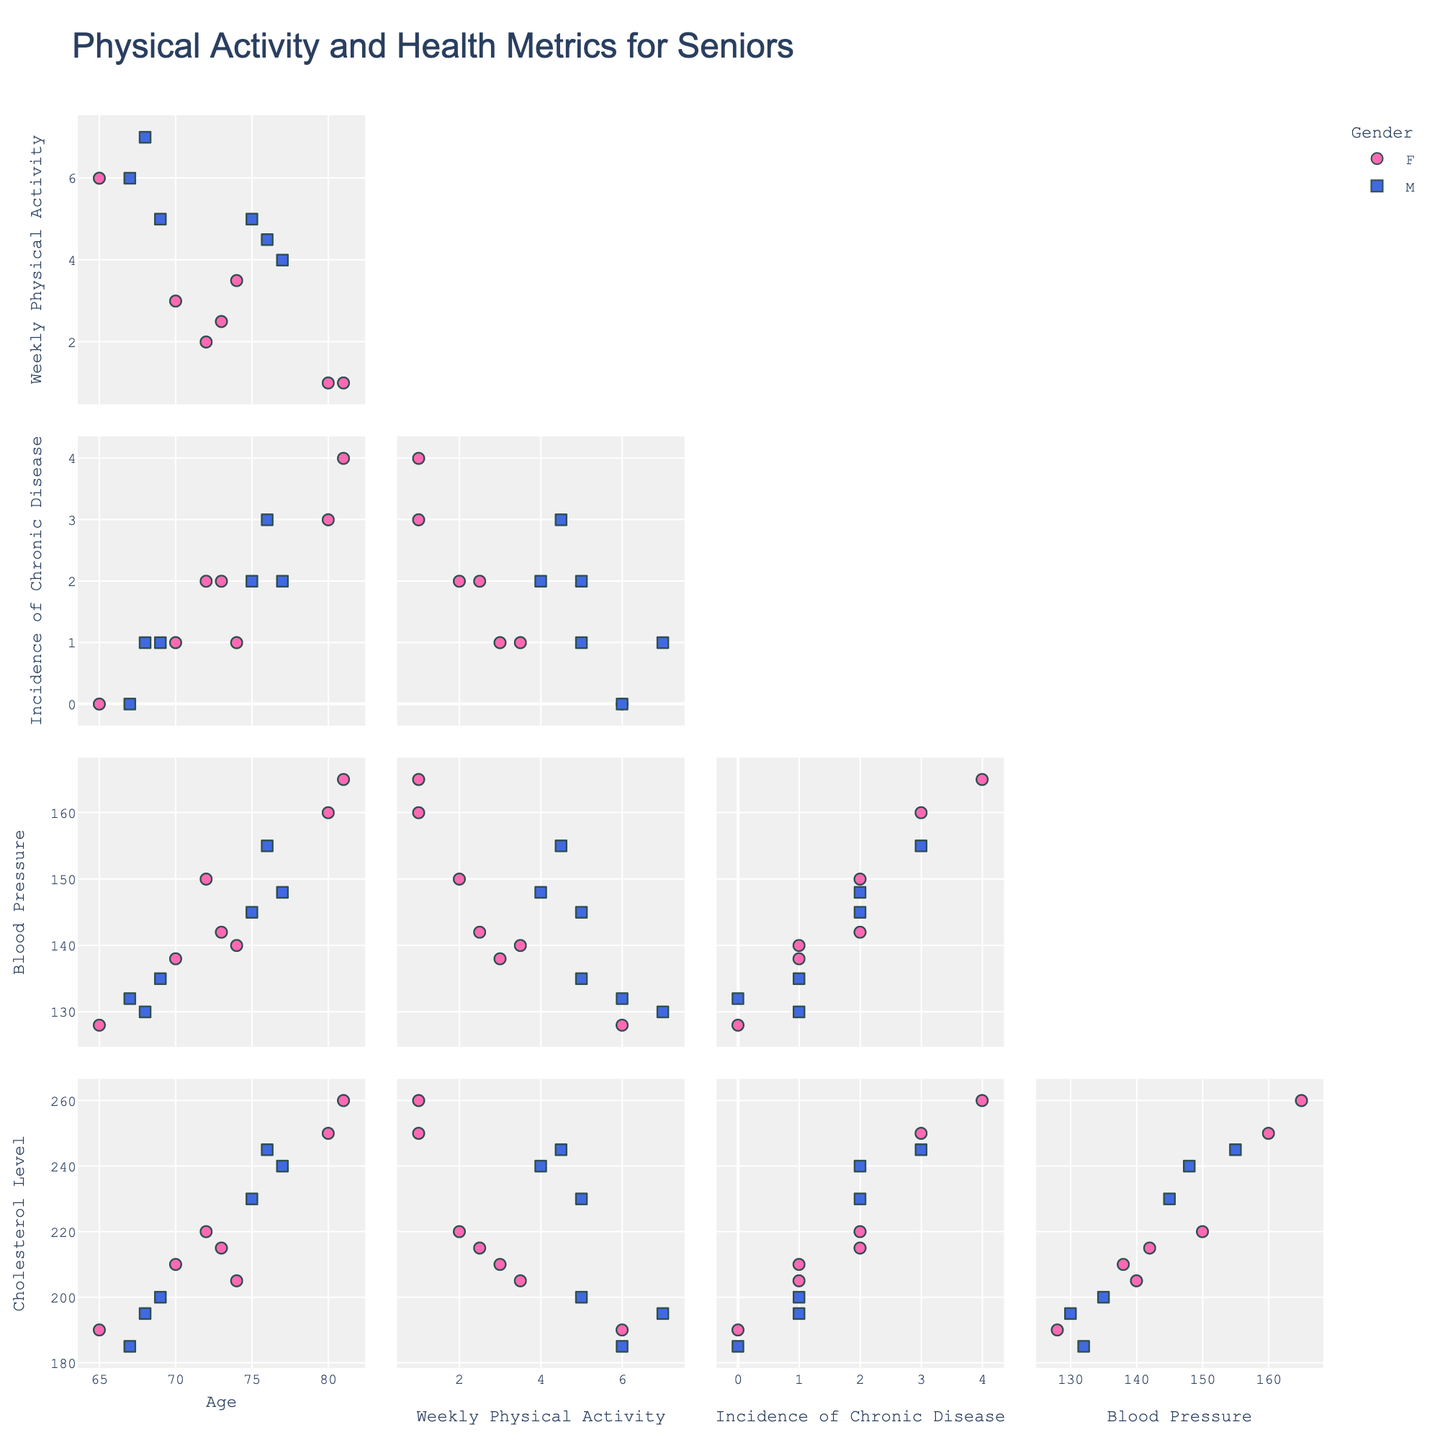What is the title of the figure? The title is usually placed at the top of the figure. It provides a summary of what the figure represents.
Answer: Physical Activity and Health Metrics for Seniors How many data points represent males and how many represent females? Check the symbols and colors used in the plot to differentiate between males and females. Count the distinct data points for each group.
Answer: Males: 6, Females: 7 Which gender shows a higher incidence of chronic disease on average? Identify the positions of data points for both genders in the "Incidence of Chronic Disease" axis. Calculate the average incidence for each gender and compare them.
Answer: Females Is there a visible trend between age and weekly physical activity? Look at the scatter plots involving the 'Age' and 'Weekly Physical Activity'. Observe if data points show any consistent pattern indicating a trend.
Answer: No strong trend Between males and females, which group has the highest blood pressure recorded? Locate the data points for both males and females on the "Blood Pressure" axis and find the maximum value for each group. Compare these values.
Answer: Females What is the range of cholesterol levels observed in the data? Identify the minimum and maximum cholesterol levels from the scatter plots. The range is the difference between the maximum and minimum values.
Answer: 190 to 260 Is there a relationship between weekly physical activity and cholesterol levels? Examine the scatter plots involving "Weekly Physical Activity" and "Cholesterol Level". Look for any noticeable patterns or correlations.
Answer: No clear relationship How does the incidence of chronic disease correlate with blood pressure? Analyze the scatter plot involving "Incidence of Chronic Disease" and "Blood Pressure". Look for any patterns indicating correlation.
Answer: Positive correlation Which variable pair shows the strongest correlation in the data? Review the scatter plots for various pairs of variables and identify the one with the most obvious linear pattern or trend.
Answer: Incidence of Chronic Disease and Blood Pressure Do seniors with more physical activity tend to have lower blood pressure? Check the scatter plots related to "Weekly Physical Activity" and "Blood Pressure". Identify if higher activity levels correspond to lower blood pressure values.
Answer: Not consistently 